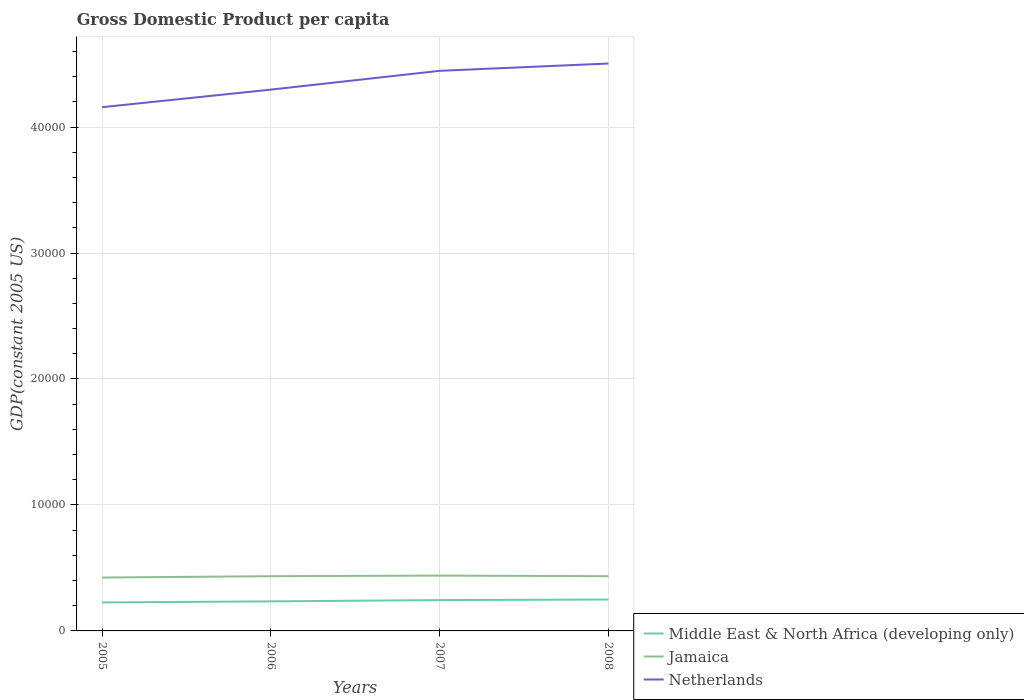How many different coloured lines are there?
Ensure brevity in your answer.  3. Across all years, what is the maximum GDP per capita in Netherlands?
Ensure brevity in your answer.  4.16e+04. In which year was the GDP per capita in Middle East & North Africa (developing only) maximum?
Provide a succinct answer. 2005. What is the total GDP per capita in Middle East & North Africa (developing only) in the graph?
Your response must be concise. -186.68. What is the difference between the highest and the second highest GDP per capita in Jamaica?
Provide a short and direct response. 153.96. Is the GDP per capita in Netherlands strictly greater than the GDP per capita in Jamaica over the years?
Keep it short and to the point. No. What is the difference between two consecutive major ticks on the Y-axis?
Your response must be concise. 10000. Does the graph contain any zero values?
Offer a terse response. No. Does the graph contain grids?
Your answer should be compact. Yes. Where does the legend appear in the graph?
Your answer should be compact. Bottom right. How many legend labels are there?
Offer a very short reply. 3. How are the legend labels stacked?
Ensure brevity in your answer.  Vertical. What is the title of the graph?
Your answer should be very brief. Gross Domestic Product per capita. What is the label or title of the X-axis?
Your answer should be very brief. Years. What is the label or title of the Y-axis?
Make the answer very short. GDP(constant 2005 US). What is the GDP(constant 2005 US) of Middle East & North Africa (developing only) in 2005?
Keep it short and to the point. 2261.6. What is the GDP(constant 2005 US) of Jamaica in 2005?
Provide a short and direct response. 4238.32. What is the GDP(constant 2005 US) of Netherlands in 2005?
Your answer should be compact. 4.16e+04. What is the GDP(constant 2005 US) in Middle East & North Africa (developing only) in 2006?
Your answer should be compact. 2345.92. What is the GDP(constant 2005 US) of Jamaica in 2006?
Your answer should be very brief. 4345.67. What is the GDP(constant 2005 US) in Netherlands in 2006?
Give a very brief answer. 4.30e+04. What is the GDP(constant 2005 US) of Middle East & North Africa (developing only) in 2007?
Provide a succinct answer. 2448.28. What is the GDP(constant 2005 US) in Jamaica in 2007?
Offer a very short reply. 4392.27. What is the GDP(constant 2005 US) in Netherlands in 2007?
Your response must be concise. 4.45e+04. What is the GDP(constant 2005 US) of Middle East & North Africa (developing only) in 2008?
Your answer should be compact. 2493.35. What is the GDP(constant 2005 US) in Jamaica in 2008?
Ensure brevity in your answer.  4345.12. What is the GDP(constant 2005 US) of Netherlands in 2008?
Your answer should be very brief. 4.50e+04. Across all years, what is the maximum GDP(constant 2005 US) of Middle East & North Africa (developing only)?
Your answer should be compact. 2493.35. Across all years, what is the maximum GDP(constant 2005 US) of Jamaica?
Your answer should be compact. 4392.27. Across all years, what is the maximum GDP(constant 2005 US) in Netherlands?
Keep it short and to the point. 4.50e+04. Across all years, what is the minimum GDP(constant 2005 US) in Middle East & North Africa (developing only)?
Offer a terse response. 2261.6. Across all years, what is the minimum GDP(constant 2005 US) in Jamaica?
Ensure brevity in your answer.  4238.32. Across all years, what is the minimum GDP(constant 2005 US) in Netherlands?
Provide a succinct answer. 4.16e+04. What is the total GDP(constant 2005 US) of Middle East & North Africa (developing only) in the graph?
Make the answer very short. 9549.15. What is the total GDP(constant 2005 US) of Jamaica in the graph?
Ensure brevity in your answer.  1.73e+04. What is the total GDP(constant 2005 US) of Netherlands in the graph?
Offer a terse response. 1.74e+05. What is the difference between the GDP(constant 2005 US) in Middle East & North Africa (developing only) in 2005 and that in 2006?
Make the answer very short. -84.32. What is the difference between the GDP(constant 2005 US) in Jamaica in 2005 and that in 2006?
Your answer should be compact. -107.35. What is the difference between the GDP(constant 2005 US) in Netherlands in 2005 and that in 2006?
Keep it short and to the point. -1393.88. What is the difference between the GDP(constant 2005 US) of Middle East & North Africa (developing only) in 2005 and that in 2007?
Ensure brevity in your answer.  -186.68. What is the difference between the GDP(constant 2005 US) of Jamaica in 2005 and that in 2007?
Your response must be concise. -153.96. What is the difference between the GDP(constant 2005 US) in Netherlands in 2005 and that in 2007?
Your answer should be very brief. -2886.33. What is the difference between the GDP(constant 2005 US) in Middle East & North Africa (developing only) in 2005 and that in 2008?
Provide a succinct answer. -231.75. What is the difference between the GDP(constant 2005 US) in Jamaica in 2005 and that in 2008?
Provide a succinct answer. -106.8. What is the difference between the GDP(constant 2005 US) in Netherlands in 2005 and that in 2008?
Offer a very short reply. -3466.1. What is the difference between the GDP(constant 2005 US) of Middle East & North Africa (developing only) in 2006 and that in 2007?
Your answer should be very brief. -102.35. What is the difference between the GDP(constant 2005 US) in Jamaica in 2006 and that in 2007?
Your response must be concise. -46.6. What is the difference between the GDP(constant 2005 US) in Netherlands in 2006 and that in 2007?
Ensure brevity in your answer.  -1492.45. What is the difference between the GDP(constant 2005 US) of Middle East & North Africa (developing only) in 2006 and that in 2008?
Provide a short and direct response. -147.43. What is the difference between the GDP(constant 2005 US) of Jamaica in 2006 and that in 2008?
Keep it short and to the point. 0.55. What is the difference between the GDP(constant 2005 US) in Netherlands in 2006 and that in 2008?
Your response must be concise. -2072.22. What is the difference between the GDP(constant 2005 US) in Middle East & North Africa (developing only) in 2007 and that in 2008?
Offer a very short reply. -45.07. What is the difference between the GDP(constant 2005 US) of Jamaica in 2007 and that in 2008?
Your answer should be very brief. 47.15. What is the difference between the GDP(constant 2005 US) in Netherlands in 2007 and that in 2008?
Offer a terse response. -579.77. What is the difference between the GDP(constant 2005 US) of Middle East & North Africa (developing only) in 2005 and the GDP(constant 2005 US) of Jamaica in 2006?
Your response must be concise. -2084.07. What is the difference between the GDP(constant 2005 US) in Middle East & North Africa (developing only) in 2005 and the GDP(constant 2005 US) in Netherlands in 2006?
Ensure brevity in your answer.  -4.07e+04. What is the difference between the GDP(constant 2005 US) in Jamaica in 2005 and the GDP(constant 2005 US) in Netherlands in 2006?
Keep it short and to the point. -3.87e+04. What is the difference between the GDP(constant 2005 US) of Middle East & North Africa (developing only) in 2005 and the GDP(constant 2005 US) of Jamaica in 2007?
Your answer should be very brief. -2130.67. What is the difference between the GDP(constant 2005 US) in Middle East & North Africa (developing only) in 2005 and the GDP(constant 2005 US) in Netherlands in 2007?
Keep it short and to the point. -4.22e+04. What is the difference between the GDP(constant 2005 US) of Jamaica in 2005 and the GDP(constant 2005 US) of Netherlands in 2007?
Keep it short and to the point. -4.02e+04. What is the difference between the GDP(constant 2005 US) of Middle East & North Africa (developing only) in 2005 and the GDP(constant 2005 US) of Jamaica in 2008?
Provide a succinct answer. -2083.52. What is the difference between the GDP(constant 2005 US) of Middle East & North Africa (developing only) in 2005 and the GDP(constant 2005 US) of Netherlands in 2008?
Offer a terse response. -4.28e+04. What is the difference between the GDP(constant 2005 US) in Jamaica in 2005 and the GDP(constant 2005 US) in Netherlands in 2008?
Provide a short and direct response. -4.08e+04. What is the difference between the GDP(constant 2005 US) of Middle East & North Africa (developing only) in 2006 and the GDP(constant 2005 US) of Jamaica in 2007?
Your answer should be very brief. -2046.35. What is the difference between the GDP(constant 2005 US) of Middle East & North Africa (developing only) in 2006 and the GDP(constant 2005 US) of Netherlands in 2007?
Give a very brief answer. -4.21e+04. What is the difference between the GDP(constant 2005 US) of Jamaica in 2006 and the GDP(constant 2005 US) of Netherlands in 2007?
Make the answer very short. -4.01e+04. What is the difference between the GDP(constant 2005 US) of Middle East & North Africa (developing only) in 2006 and the GDP(constant 2005 US) of Jamaica in 2008?
Your answer should be compact. -1999.2. What is the difference between the GDP(constant 2005 US) in Middle East & North Africa (developing only) in 2006 and the GDP(constant 2005 US) in Netherlands in 2008?
Your response must be concise. -4.27e+04. What is the difference between the GDP(constant 2005 US) of Jamaica in 2006 and the GDP(constant 2005 US) of Netherlands in 2008?
Your response must be concise. -4.07e+04. What is the difference between the GDP(constant 2005 US) in Middle East & North Africa (developing only) in 2007 and the GDP(constant 2005 US) in Jamaica in 2008?
Your answer should be very brief. -1896.84. What is the difference between the GDP(constant 2005 US) in Middle East & North Africa (developing only) in 2007 and the GDP(constant 2005 US) in Netherlands in 2008?
Offer a very short reply. -4.26e+04. What is the difference between the GDP(constant 2005 US) of Jamaica in 2007 and the GDP(constant 2005 US) of Netherlands in 2008?
Give a very brief answer. -4.07e+04. What is the average GDP(constant 2005 US) of Middle East & North Africa (developing only) per year?
Your answer should be very brief. 2387.29. What is the average GDP(constant 2005 US) in Jamaica per year?
Provide a short and direct response. 4330.34. What is the average GDP(constant 2005 US) of Netherlands per year?
Keep it short and to the point. 4.35e+04. In the year 2005, what is the difference between the GDP(constant 2005 US) of Middle East & North Africa (developing only) and GDP(constant 2005 US) of Jamaica?
Your answer should be very brief. -1976.71. In the year 2005, what is the difference between the GDP(constant 2005 US) in Middle East & North Africa (developing only) and GDP(constant 2005 US) in Netherlands?
Provide a short and direct response. -3.93e+04. In the year 2005, what is the difference between the GDP(constant 2005 US) in Jamaica and GDP(constant 2005 US) in Netherlands?
Provide a short and direct response. -3.73e+04. In the year 2006, what is the difference between the GDP(constant 2005 US) of Middle East & North Africa (developing only) and GDP(constant 2005 US) of Jamaica?
Provide a succinct answer. -1999.75. In the year 2006, what is the difference between the GDP(constant 2005 US) in Middle East & North Africa (developing only) and GDP(constant 2005 US) in Netherlands?
Make the answer very short. -4.06e+04. In the year 2006, what is the difference between the GDP(constant 2005 US) in Jamaica and GDP(constant 2005 US) in Netherlands?
Keep it short and to the point. -3.86e+04. In the year 2007, what is the difference between the GDP(constant 2005 US) of Middle East & North Africa (developing only) and GDP(constant 2005 US) of Jamaica?
Make the answer very short. -1943.99. In the year 2007, what is the difference between the GDP(constant 2005 US) in Middle East & North Africa (developing only) and GDP(constant 2005 US) in Netherlands?
Ensure brevity in your answer.  -4.20e+04. In the year 2007, what is the difference between the GDP(constant 2005 US) in Jamaica and GDP(constant 2005 US) in Netherlands?
Provide a short and direct response. -4.01e+04. In the year 2008, what is the difference between the GDP(constant 2005 US) in Middle East & North Africa (developing only) and GDP(constant 2005 US) in Jamaica?
Your response must be concise. -1851.77. In the year 2008, what is the difference between the GDP(constant 2005 US) in Middle East & North Africa (developing only) and GDP(constant 2005 US) in Netherlands?
Provide a short and direct response. -4.25e+04. In the year 2008, what is the difference between the GDP(constant 2005 US) in Jamaica and GDP(constant 2005 US) in Netherlands?
Your response must be concise. -4.07e+04. What is the ratio of the GDP(constant 2005 US) of Middle East & North Africa (developing only) in 2005 to that in 2006?
Offer a terse response. 0.96. What is the ratio of the GDP(constant 2005 US) in Jamaica in 2005 to that in 2006?
Offer a terse response. 0.98. What is the ratio of the GDP(constant 2005 US) in Netherlands in 2005 to that in 2006?
Your response must be concise. 0.97. What is the ratio of the GDP(constant 2005 US) of Middle East & North Africa (developing only) in 2005 to that in 2007?
Keep it short and to the point. 0.92. What is the ratio of the GDP(constant 2005 US) in Jamaica in 2005 to that in 2007?
Offer a very short reply. 0.96. What is the ratio of the GDP(constant 2005 US) in Netherlands in 2005 to that in 2007?
Provide a succinct answer. 0.94. What is the ratio of the GDP(constant 2005 US) of Middle East & North Africa (developing only) in 2005 to that in 2008?
Provide a succinct answer. 0.91. What is the ratio of the GDP(constant 2005 US) in Jamaica in 2005 to that in 2008?
Give a very brief answer. 0.98. What is the ratio of the GDP(constant 2005 US) in Netherlands in 2005 to that in 2008?
Provide a short and direct response. 0.92. What is the ratio of the GDP(constant 2005 US) of Middle East & North Africa (developing only) in 2006 to that in 2007?
Keep it short and to the point. 0.96. What is the ratio of the GDP(constant 2005 US) of Jamaica in 2006 to that in 2007?
Give a very brief answer. 0.99. What is the ratio of the GDP(constant 2005 US) of Netherlands in 2006 to that in 2007?
Your response must be concise. 0.97. What is the ratio of the GDP(constant 2005 US) of Middle East & North Africa (developing only) in 2006 to that in 2008?
Give a very brief answer. 0.94. What is the ratio of the GDP(constant 2005 US) in Jamaica in 2006 to that in 2008?
Give a very brief answer. 1. What is the ratio of the GDP(constant 2005 US) in Netherlands in 2006 to that in 2008?
Offer a terse response. 0.95. What is the ratio of the GDP(constant 2005 US) in Middle East & North Africa (developing only) in 2007 to that in 2008?
Provide a succinct answer. 0.98. What is the ratio of the GDP(constant 2005 US) of Jamaica in 2007 to that in 2008?
Your response must be concise. 1.01. What is the ratio of the GDP(constant 2005 US) in Netherlands in 2007 to that in 2008?
Provide a succinct answer. 0.99. What is the difference between the highest and the second highest GDP(constant 2005 US) of Middle East & North Africa (developing only)?
Give a very brief answer. 45.07. What is the difference between the highest and the second highest GDP(constant 2005 US) of Jamaica?
Provide a succinct answer. 46.6. What is the difference between the highest and the second highest GDP(constant 2005 US) in Netherlands?
Your answer should be very brief. 579.77. What is the difference between the highest and the lowest GDP(constant 2005 US) of Middle East & North Africa (developing only)?
Keep it short and to the point. 231.75. What is the difference between the highest and the lowest GDP(constant 2005 US) of Jamaica?
Your answer should be very brief. 153.96. What is the difference between the highest and the lowest GDP(constant 2005 US) of Netherlands?
Provide a succinct answer. 3466.1. 